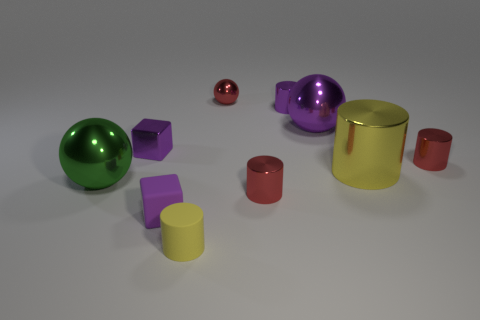What size is the purple shiny ball?
Give a very brief answer. Large. There is a rubber object that is the same color as the big cylinder; what is its shape?
Provide a short and direct response. Cylinder. Is the number of things greater than the number of large metallic things?
Make the answer very short. Yes. There is a big shiny ball that is behind the large thing that is on the left side of the thing that is behind the small purple cylinder; what is its color?
Make the answer very short. Purple. There is a yellow object on the right side of the tiny red metal ball; is its shape the same as the large purple metal thing?
Ensure brevity in your answer.  No. What color is the sphere that is the same size as the rubber block?
Offer a very short reply. Red. What number of big purple metallic objects are there?
Make the answer very short. 1. Is the yellow cylinder to the right of the red ball made of the same material as the large purple object?
Provide a short and direct response. Yes. What is the big object that is left of the big yellow cylinder and to the right of the matte cylinder made of?
Your answer should be compact. Metal. There is a sphere that is the same color as the small matte cube; what is its size?
Your answer should be compact. Large. 